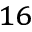<formula> <loc_0><loc_0><loc_500><loc_500>_ { 1 6 }</formula> 